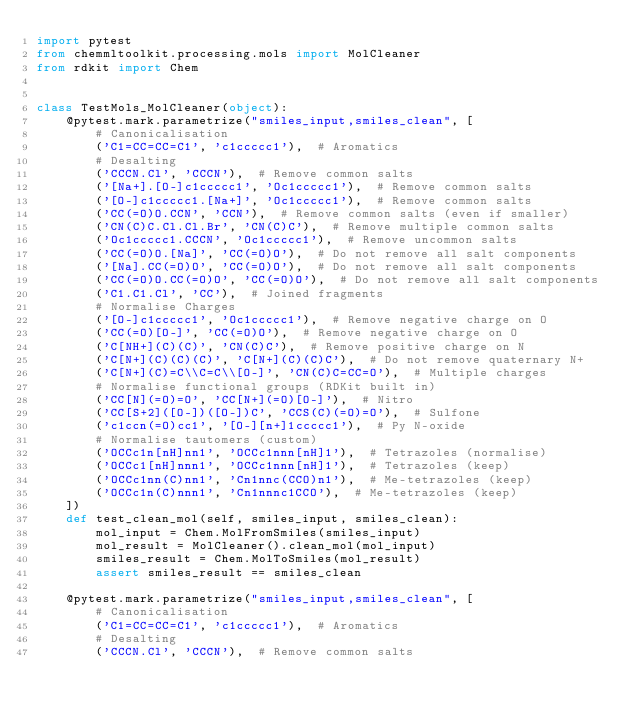Convert code to text. <code><loc_0><loc_0><loc_500><loc_500><_Python_>import pytest
from chemmltoolkit.processing.mols import MolCleaner
from rdkit import Chem


class TestMols_MolCleaner(object):
    @pytest.mark.parametrize("smiles_input,smiles_clean", [
        # Canonicalisation
        ('C1=CC=CC=C1', 'c1ccccc1'),  # Aromatics
        # Desalting
        ('CCCN.Cl', 'CCCN'),  # Remove common salts
        ('[Na+].[O-]c1ccccc1', 'Oc1ccccc1'),  # Remove common salts
        ('[O-]c1ccccc1.[Na+]', 'Oc1ccccc1'),  # Remove common salts
        ('CC(=O)O.CCN', 'CCN'),  # Remove common salts (even if smaller)
        ('CN(C)C.Cl.Cl.Br', 'CN(C)C'),  # Remove multiple common salts
        ('Oc1ccccc1.CCCN', 'Oc1ccccc1'),  # Remove uncommon salts
        ('CC(=O)O.[Na]', 'CC(=O)O'),  # Do not remove all salt components
        ('[Na].CC(=O)O', 'CC(=O)O'),  # Do not remove all salt components
        ('CC(=O)O.CC(=O)O', 'CC(=O)O'),  # Do not remove all salt components
        ('C1.C1.Cl', 'CC'),  # Joined fragments
        # Normalise Charges
        ('[O-]c1ccccc1', 'Oc1ccccc1'),  # Remove negative charge on O
        ('CC(=O)[O-]', 'CC(=O)O'),  # Remove negative charge on O
        ('C[NH+](C)(C)', 'CN(C)C'),  # Remove positive charge on N
        ('C[N+](C)(C)(C)', 'C[N+](C)(C)C'),  # Do not remove quaternary N+
        ('C[N+](C)=C\\C=C\\[O-]', 'CN(C)C=CC=O'),  # Multiple charges
        # Normalise functional groups (RDKit built in)
        ('CC[N](=O)=O', 'CC[N+](=O)[O-]'),  # Nitro
        ('CC[S+2]([O-])([O-])C', 'CCS(C)(=O)=O'),  # Sulfone
        ('c1ccn(=O)cc1', '[O-][n+]1ccccc1'),  # Py N-oxide
        # Normalise tautomers (custom)
        ('OCCc1n[nH]nn1', 'OCCc1nnn[nH]1'),  # Tetrazoles (normalise)
        ('OCCc1[nH]nnn1', 'OCCc1nnn[nH]1'),  # Tetrazoles (keep)
        ('OCCc1nn(C)nn1', 'Cn1nnc(CCO)n1'),  # Me-tetrazoles (keep)
        ('OCCc1n(C)nnn1', 'Cn1nnnc1CCO'),  # Me-tetrazoles (keep)
    ])
    def test_clean_mol(self, smiles_input, smiles_clean):
        mol_input = Chem.MolFromSmiles(smiles_input)
        mol_result = MolCleaner().clean_mol(mol_input)
        smiles_result = Chem.MolToSmiles(mol_result)
        assert smiles_result == smiles_clean

    @pytest.mark.parametrize("smiles_input,smiles_clean", [
        # Canonicalisation
        ('C1=CC=CC=C1', 'c1ccccc1'),  # Aromatics
        # Desalting
        ('CCCN.Cl', 'CCCN'),  # Remove common salts</code> 